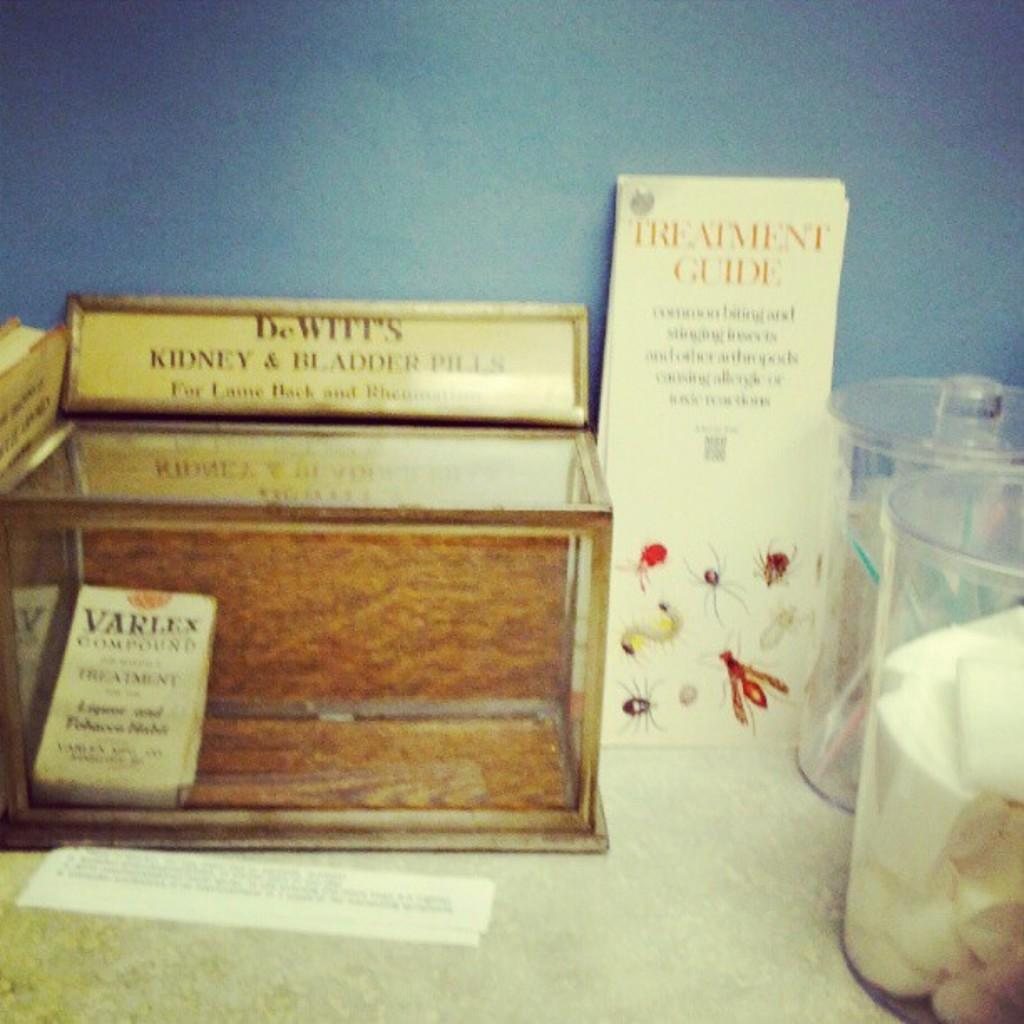<image>
Create a compact narrative representing the image presented. A small book titled "Varlex Compound" and a Treatment Guide. 